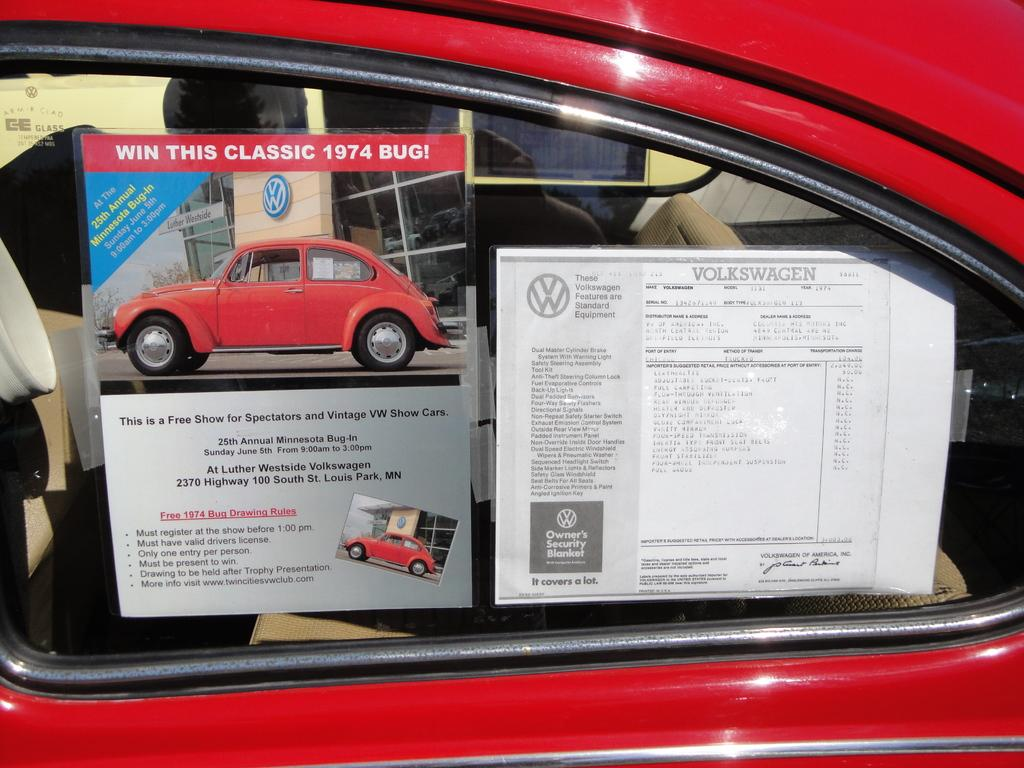What is the main subject of the image? The main subject of the image is a car. Can you describe the car's appearance? The car is red. Are there any additional details about the car that can be observed? Yes, there are papers pasted on the car's mirror. What type of camera is visible on the car's dashboard in the image? There is no camera visible on the car's dashboard in the image. How does the hair on the car's hood look like in the image? There is no hair present on the car's hood in the image. 